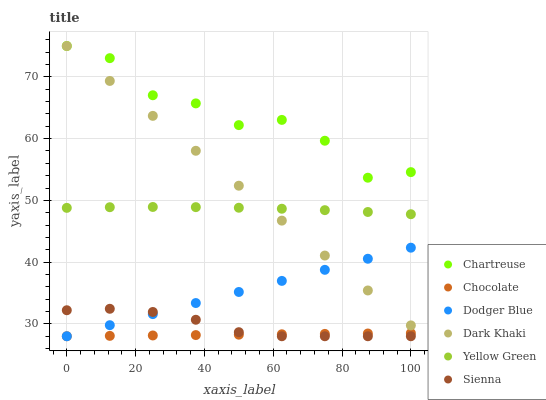Does Chocolate have the minimum area under the curve?
Answer yes or no. Yes. Does Chartreuse have the maximum area under the curve?
Answer yes or no. Yes. Does Yellow Green have the minimum area under the curve?
Answer yes or no. No. Does Yellow Green have the maximum area under the curve?
Answer yes or no. No. Is Chocolate the smoothest?
Answer yes or no. Yes. Is Chartreuse the roughest?
Answer yes or no. Yes. Is Yellow Green the smoothest?
Answer yes or no. No. Is Yellow Green the roughest?
Answer yes or no. No. Does Sienna have the lowest value?
Answer yes or no. Yes. Does Yellow Green have the lowest value?
Answer yes or no. No. Does Chartreuse have the highest value?
Answer yes or no. Yes. Does Yellow Green have the highest value?
Answer yes or no. No. Is Chocolate less than Yellow Green?
Answer yes or no. Yes. Is Dark Khaki greater than Sienna?
Answer yes or no. Yes. Does Dark Khaki intersect Yellow Green?
Answer yes or no. Yes. Is Dark Khaki less than Yellow Green?
Answer yes or no. No. Is Dark Khaki greater than Yellow Green?
Answer yes or no. No. Does Chocolate intersect Yellow Green?
Answer yes or no. No. 